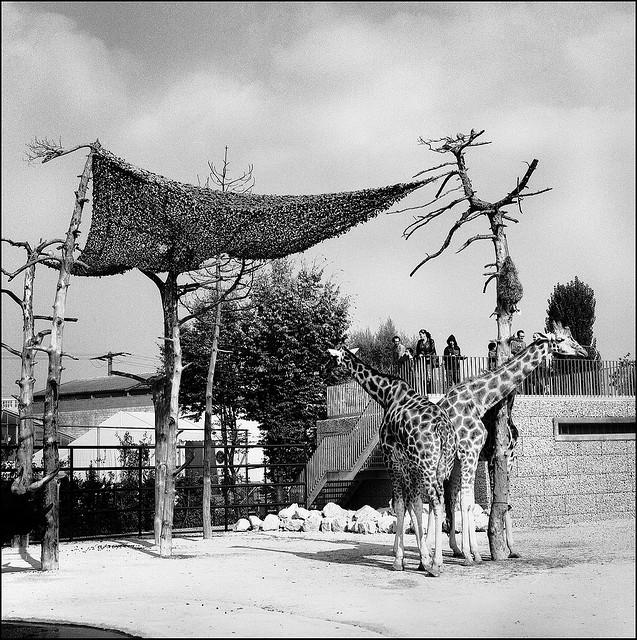Why are the people behind rails? Please explain your reasoning. protect them. Giraffes are wild animals and cannot be in close proximity to people as it is not known how they would interact with them up close. 